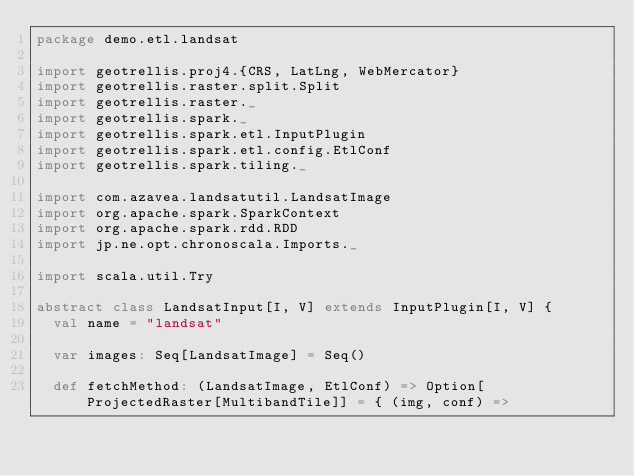<code> <loc_0><loc_0><loc_500><loc_500><_Scala_>package demo.etl.landsat

import geotrellis.proj4.{CRS, LatLng, WebMercator}
import geotrellis.raster.split.Split
import geotrellis.raster._
import geotrellis.spark._
import geotrellis.spark.etl.InputPlugin
import geotrellis.spark.etl.config.EtlConf
import geotrellis.spark.tiling._

import com.azavea.landsatutil.LandsatImage
import org.apache.spark.SparkContext
import org.apache.spark.rdd.RDD
import jp.ne.opt.chronoscala.Imports._

import scala.util.Try

abstract class LandsatInput[I, V] extends InputPlugin[I, V] {
  val name = "landsat"

  var images: Seq[LandsatImage] = Seq()

  def fetchMethod: (LandsatImage, EtlConf) => Option[ProjectedRaster[MultibandTile]] = { (img, conf) =></code> 